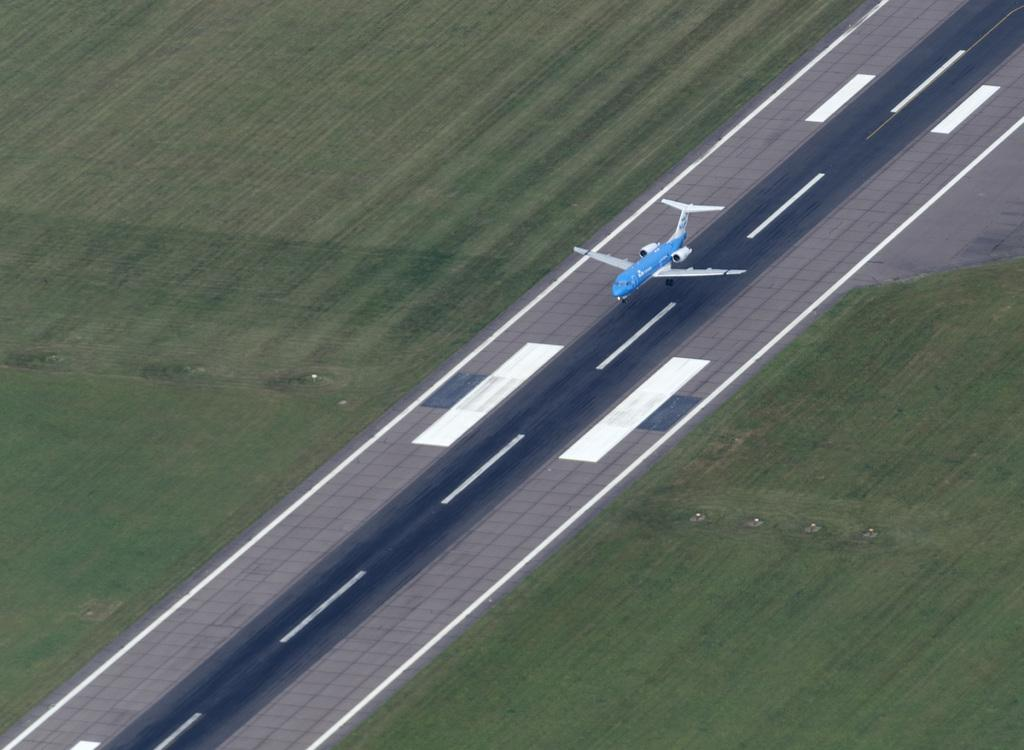What is the color of the plane in the image? The plane in the image is blue. What is the plane doing in the image? The plane is flying above a runway. What can be seen on both sides of the runway? There is green grass on both sides of the runway. Where is the secretary sitting with the fish in the image? There is no secretary or fish present in the image; it only features a blue color plane flying above a runway. 